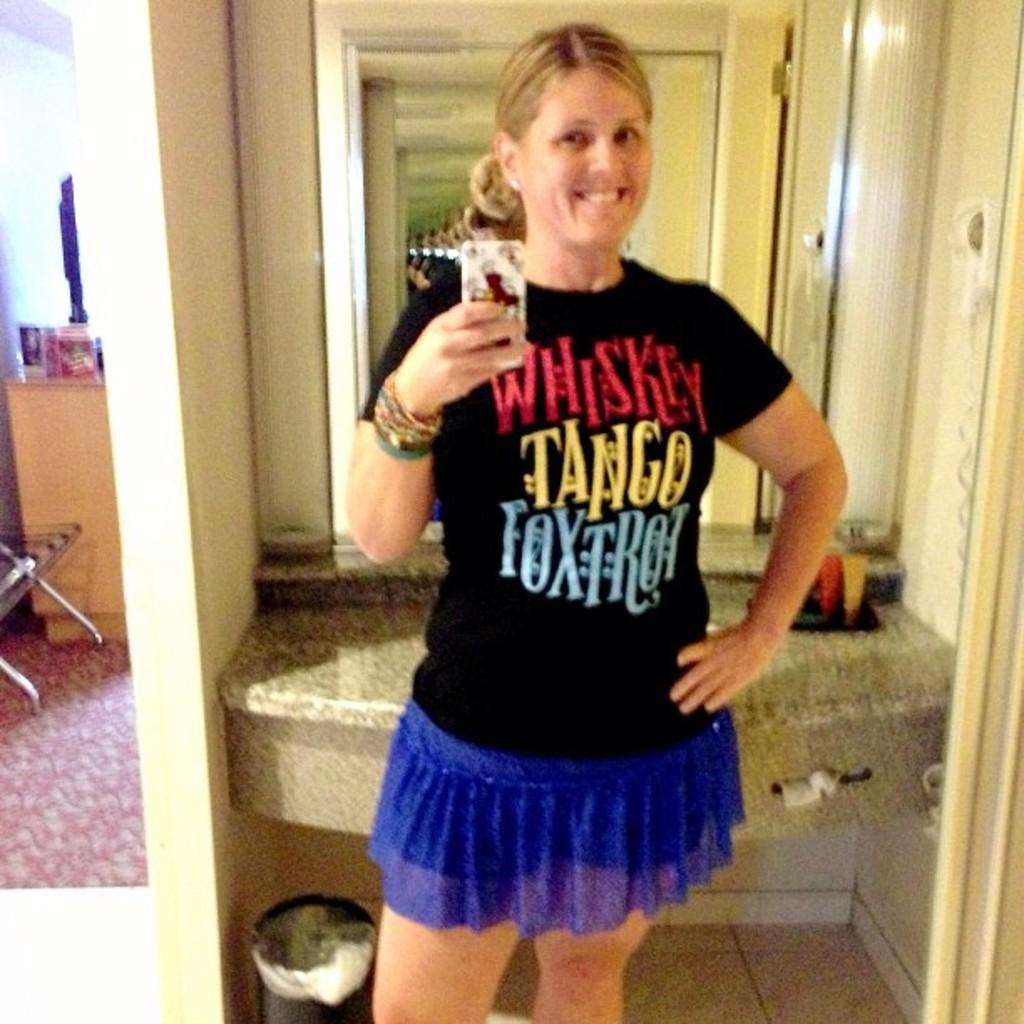<image>
Give a short and clear explanation of the subsequent image. A woman wearing a shirt that says, "Whiskey Tango Foxtrot", is taking a selfie. 